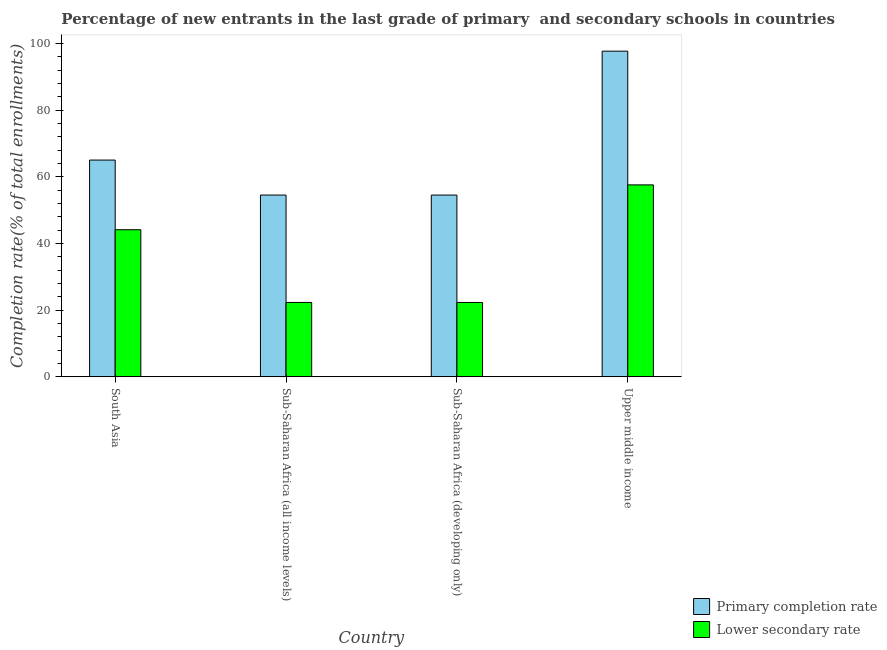How many groups of bars are there?
Give a very brief answer. 4. How many bars are there on the 1st tick from the left?
Offer a very short reply. 2. How many bars are there on the 3rd tick from the right?
Ensure brevity in your answer.  2. What is the label of the 2nd group of bars from the left?
Your response must be concise. Sub-Saharan Africa (all income levels). In how many cases, is the number of bars for a given country not equal to the number of legend labels?
Provide a succinct answer. 0. What is the completion rate in primary schools in Upper middle income?
Keep it short and to the point. 97.69. Across all countries, what is the maximum completion rate in secondary schools?
Your response must be concise. 57.58. Across all countries, what is the minimum completion rate in secondary schools?
Give a very brief answer. 22.32. In which country was the completion rate in primary schools maximum?
Provide a short and direct response. Upper middle income. In which country was the completion rate in primary schools minimum?
Offer a terse response. Sub-Saharan Africa (developing only). What is the total completion rate in primary schools in the graph?
Make the answer very short. 271.78. What is the difference between the completion rate in secondary schools in South Asia and that in Sub-Saharan Africa (all income levels)?
Provide a succinct answer. 21.81. What is the difference between the completion rate in primary schools in Sub-Saharan Africa (developing only) and the completion rate in secondary schools in South Asia?
Provide a succinct answer. 10.39. What is the average completion rate in secondary schools per country?
Keep it short and to the point. 36.59. What is the difference between the completion rate in primary schools and completion rate in secondary schools in Upper middle income?
Offer a very short reply. 40.11. What is the ratio of the completion rate in primary schools in Sub-Saharan Africa (all income levels) to that in Sub-Saharan Africa (developing only)?
Your answer should be compact. 1. Is the completion rate in primary schools in South Asia less than that in Upper middle income?
Offer a very short reply. Yes. Is the difference between the completion rate in secondary schools in South Asia and Upper middle income greater than the difference between the completion rate in primary schools in South Asia and Upper middle income?
Your response must be concise. Yes. What is the difference between the highest and the second highest completion rate in secondary schools?
Provide a succinct answer. 13.45. What is the difference between the highest and the lowest completion rate in primary schools?
Offer a very short reply. 43.17. In how many countries, is the completion rate in primary schools greater than the average completion rate in primary schools taken over all countries?
Provide a succinct answer. 1. What does the 2nd bar from the left in South Asia represents?
Offer a terse response. Lower secondary rate. What does the 1st bar from the right in South Asia represents?
Keep it short and to the point. Lower secondary rate. Are all the bars in the graph horizontal?
Make the answer very short. No. How many countries are there in the graph?
Your answer should be compact. 4. What is the difference between two consecutive major ticks on the Y-axis?
Offer a very short reply. 20. Are the values on the major ticks of Y-axis written in scientific E-notation?
Your answer should be very brief. No. Does the graph contain any zero values?
Keep it short and to the point. No. Does the graph contain grids?
Offer a very short reply. No. Where does the legend appear in the graph?
Give a very brief answer. Bottom right. How many legend labels are there?
Provide a succinct answer. 2. What is the title of the graph?
Keep it short and to the point. Percentage of new entrants in the last grade of primary  and secondary schools in countries. Does "Attending school" appear as one of the legend labels in the graph?
Make the answer very short. No. What is the label or title of the X-axis?
Give a very brief answer. Country. What is the label or title of the Y-axis?
Give a very brief answer. Completion rate(% of total enrollments). What is the Completion rate(% of total enrollments) of Primary completion rate in South Asia?
Give a very brief answer. 65.03. What is the Completion rate(% of total enrollments) in Lower secondary rate in South Asia?
Your response must be concise. 44.14. What is the Completion rate(% of total enrollments) in Primary completion rate in Sub-Saharan Africa (all income levels)?
Your response must be concise. 54.53. What is the Completion rate(% of total enrollments) of Lower secondary rate in Sub-Saharan Africa (all income levels)?
Provide a short and direct response. 22.32. What is the Completion rate(% of total enrollments) in Primary completion rate in Sub-Saharan Africa (developing only)?
Offer a very short reply. 54.53. What is the Completion rate(% of total enrollments) in Lower secondary rate in Sub-Saharan Africa (developing only)?
Your answer should be compact. 22.32. What is the Completion rate(% of total enrollments) of Primary completion rate in Upper middle income?
Make the answer very short. 97.69. What is the Completion rate(% of total enrollments) of Lower secondary rate in Upper middle income?
Offer a terse response. 57.58. Across all countries, what is the maximum Completion rate(% of total enrollments) in Primary completion rate?
Give a very brief answer. 97.69. Across all countries, what is the maximum Completion rate(% of total enrollments) in Lower secondary rate?
Provide a succinct answer. 57.58. Across all countries, what is the minimum Completion rate(% of total enrollments) of Primary completion rate?
Keep it short and to the point. 54.53. Across all countries, what is the minimum Completion rate(% of total enrollments) of Lower secondary rate?
Give a very brief answer. 22.32. What is the total Completion rate(% of total enrollments) in Primary completion rate in the graph?
Your answer should be compact. 271.78. What is the total Completion rate(% of total enrollments) of Lower secondary rate in the graph?
Your answer should be very brief. 146.36. What is the difference between the Completion rate(% of total enrollments) of Primary completion rate in South Asia and that in Sub-Saharan Africa (all income levels)?
Offer a terse response. 10.5. What is the difference between the Completion rate(% of total enrollments) in Lower secondary rate in South Asia and that in Sub-Saharan Africa (all income levels)?
Make the answer very short. 21.81. What is the difference between the Completion rate(% of total enrollments) in Primary completion rate in South Asia and that in Sub-Saharan Africa (developing only)?
Ensure brevity in your answer.  10.5. What is the difference between the Completion rate(% of total enrollments) in Lower secondary rate in South Asia and that in Sub-Saharan Africa (developing only)?
Your response must be concise. 21.82. What is the difference between the Completion rate(% of total enrollments) in Primary completion rate in South Asia and that in Upper middle income?
Ensure brevity in your answer.  -32.66. What is the difference between the Completion rate(% of total enrollments) of Lower secondary rate in South Asia and that in Upper middle income?
Offer a terse response. -13.45. What is the difference between the Completion rate(% of total enrollments) in Primary completion rate in Sub-Saharan Africa (all income levels) and that in Sub-Saharan Africa (developing only)?
Make the answer very short. 0.01. What is the difference between the Completion rate(% of total enrollments) of Lower secondary rate in Sub-Saharan Africa (all income levels) and that in Sub-Saharan Africa (developing only)?
Ensure brevity in your answer.  0.01. What is the difference between the Completion rate(% of total enrollments) in Primary completion rate in Sub-Saharan Africa (all income levels) and that in Upper middle income?
Provide a succinct answer. -43.16. What is the difference between the Completion rate(% of total enrollments) of Lower secondary rate in Sub-Saharan Africa (all income levels) and that in Upper middle income?
Your answer should be compact. -35.26. What is the difference between the Completion rate(% of total enrollments) of Primary completion rate in Sub-Saharan Africa (developing only) and that in Upper middle income?
Offer a terse response. -43.17. What is the difference between the Completion rate(% of total enrollments) in Lower secondary rate in Sub-Saharan Africa (developing only) and that in Upper middle income?
Your response must be concise. -35.27. What is the difference between the Completion rate(% of total enrollments) in Primary completion rate in South Asia and the Completion rate(% of total enrollments) in Lower secondary rate in Sub-Saharan Africa (all income levels)?
Provide a succinct answer. 42.7. What is the difference between the Completion rate(% of total enrollments) in Primary completion rate in South Asia and the Completion rate(% of total enrollments) in Lower secondary rate in Sub-Saharan Africa (developing only)?
Make the answer very short. 42.71. What is the difference between the Completion rate(% of total enrollments) in Primary completion rate in South Asia and the Completion rate(% of total enrollments) in Lower secondary rate in Upper middle income?
Offer a very short reply. 7.44. What is the difference between the Completion rate(% of total enrollments) of Primary completion rate in Sub-Saharan Africa (all income levels) and the Completion rate(% of total enrollments) of Lower secondary rate in Sub-Saharan Africa (developing only)?
Give a very brief answer. 32.22. What is the difference between the Completion rate(% of total enrollments) in Primary completion rate in Sub-Saharan Africa (all income levels) and the Completion rate(% of total enrollments) in Lower secondary rate in Upper middle income?
Provide a short and direct response. -3.05. What is the difference between the Completion rate(% of total enrollments) in Primary completion rate in Sub-Saharan Africa (developing only) and the Completion rate(% of total enrollments) in Lower secondary rate in Upper middle income?
Your answer should be compact. -3.06. What is the average Completion rate(% of total enrollments) of Primary completion rate per country?
Your answer should be compact. 67.95. What is the average Completion rate(% of total enrollments) of Lower secondary rate per country?
Make the answer very short. 36.59. What is the difference between the Completion rate(% of total enrollments) in Primary completion rate and Completion rate(% of total enrollments) in Lower secondary rate in South Asia?
Keep it short and to the point. 20.89. What is the difference between the Completion rate(% of total enrollments) in Primary completion rate and Completion rate(% of total enrollments) in Lower secondary rate in Sub-Saharan Africa (all income levels)?
Your answer should be very brief. 32.21. What is the difference between the Completion rate(% of total enrollments) in Primary completion rate and Completion rate(% of total enrollments) in Lower secondary rate in Sub-Saharan Africa (developing only)?
Offer a very short reply. 32.21. What is the difference between the Completion rate(% of total enrollments) in Primary completion rate and Completion rate(% of total enrollments) in Lower secondary rate in Upper middle income?
Offer a terse response. 40.11. What is the ratio of the Completion rate(% of total enrollments) of Primary completion rate in South Asia to that in Sub-Saharan Africa (all income levels)?
Provide a short and direct response. 1.19. What is the ratio of the Completion rate(% of total enrollments) of Lower secondary rate in South Asia to that in Sub-Saharan Africa (all income levels)?
Your answer should be compact. 1.98. What is the ratio of the Completion rate(% of total enrollments) in Primary completion rate in South Asia to that in Sub-Saharan Africa (developing only)?
Your answer should be compact. 1.19. What is the ratio of the Completion rate(% of total enrollments) in Lower secondary rate in South Asia to that in Sub-Saharan Africa (developing only)?
Your answer should be very brief. 1.98. What is the ratio of the Completion rate(% of total enrollments) of Primary completion rate in South Asia to that in Upper middle income?
Ensure brevity in your answer.  0.67. What is the ratio of the Completion rate(% of total enrollments) in Lower secondary rate in South Asia to that in Upper middle income?
Make the answer very short. 0.77. What is the ratio of the Completion rate(% of total enrollments) of Primary completion rate in Sub-Saharan Africa (all income levels) to that in Sub-Saharan Africa (developing only)?
Ensure brevity in your answer.  1. What is the ratio of the Completion rate(% of total enrollments) of Lower secondary rate in Sub-Saharan Africa (all income levels) to that in Sub-Saharan Africa (developing only)?
Your response must be concise. 1. What is the ratio of the Completion rate(% of total enrollments) of Primary completion rate in Sub-Saharan Africa (all income levels) to that in Upper middle income?
Give a very brief answer. 0.56. What is the ratio of the Completion rate(% of total enrollments) of Lower secondary rate in Sub-Saharan Africa (all income levels) to that in Upper middle income?
Provide a short and direct response. 0.39. What is the ratio of the Completion rate(% of total enrollments) of Primary completion rate in Sub-Saharan Africa (developing only) to that in Upper middle income?
Ensure brevity in your answer.  0.56. What is the ratio of the Completion rate(% of total enrollments) in Lower secondary rate in Sub-Saharan Africa (developing only) to that in Upper middle income?
Offer a terse response. 0.39. What is the difference between the highest and the second highest Completion rate(% of total enrollments) in Primary completion rate?
Give a very brief answer. 32.66. What is the difference between the highest and the second highest Completion rate(% of total enrollments) of Lower secondary rate?
Provide a succinct answer. 13.45. What is the difference between the highest and the lowest Completion rate(% of total enrollments) of Primary completion rate?
Your answer should be very brief. 43.17. What is the difference between the highest and the lowest Completion rate(% of total enrollments) in Lower secondary rate?
Offer a very short reply. 35.27. 